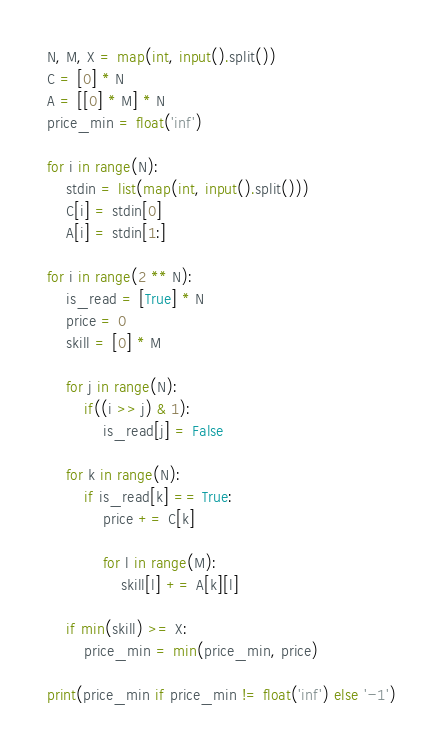Convert code to text. <code><loc_0><loc_0><loc_500><loc_500><_Python_>N, M, X = map(int, input().split())
C = [0] * N
A = [[0] * M] * N
price_min = float('inf')

for i in range(N):
    stdin = list(map(int, input().split()))
    C[i] = stdin[0]
    A[i] = stdin[1:]

for i in range(2 ** N):
    is_read = [True] * N
    price = 0
    skill = [0] * M

    for j in range(N):
        if((i >> j) & 1):
            is_read[j] = False

    for k in range(N):
        if is_read[k] == True:
            price += C[k]

            for l in range(M):
                skill[l] += A[k][l]

    if min(skill) >= X:
        price_min = min(price_min, price)

print(price_min if price_min != float('inf') else '-1')</code> 